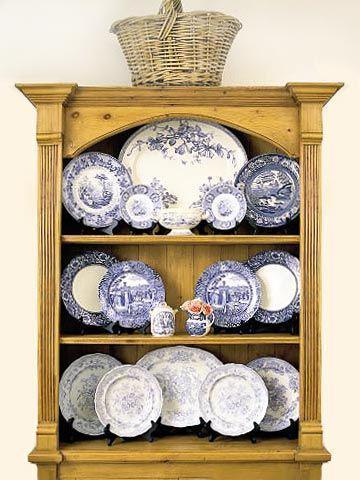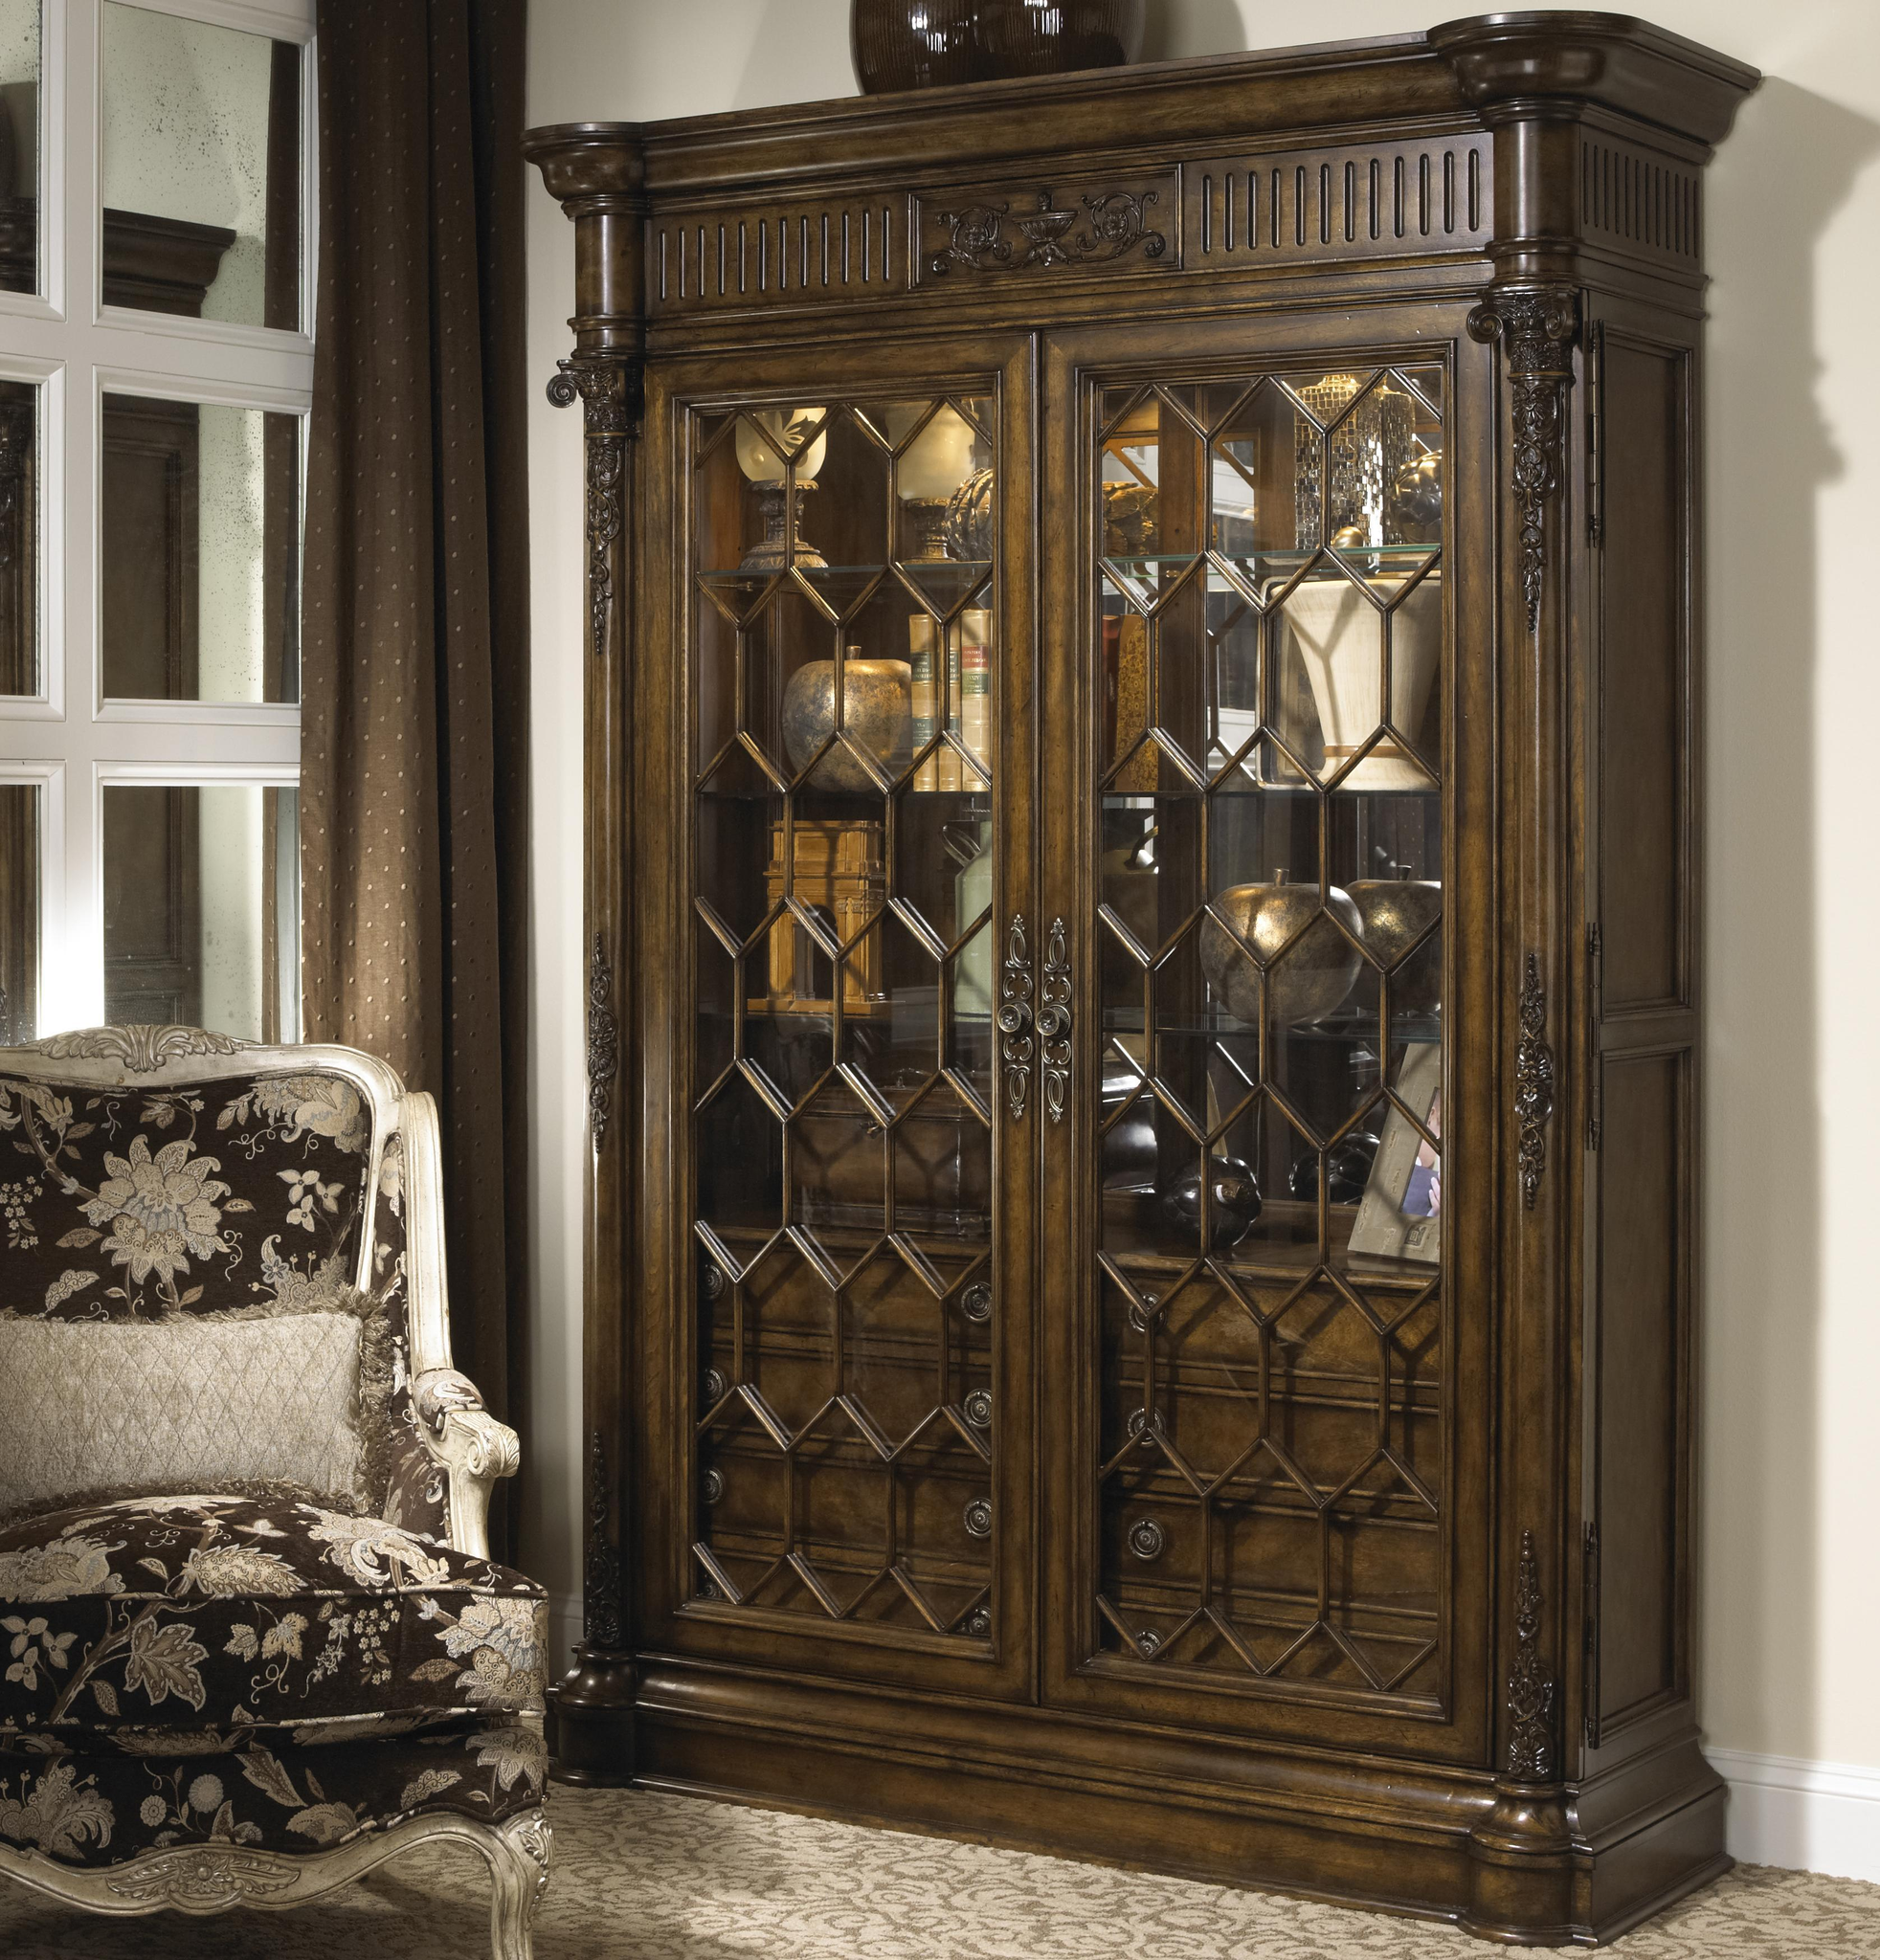The first image is the image on the left, the second image is the image on the right. Examine the images to the left and right. Is the description "Blue and white patterned plates are displayed on the shelves of one china cabinet." accurate? Answer yes or no. Yes. 